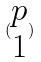<formula> <loc_0><loc_0><loc_500><loc_500>( \begin{matrix} p \\ 1 \end{matrix} )</formula> 